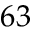Convert formula to latex. <formula><loc_0><loc_0><loc_500><loc_500>6 3</formula> 